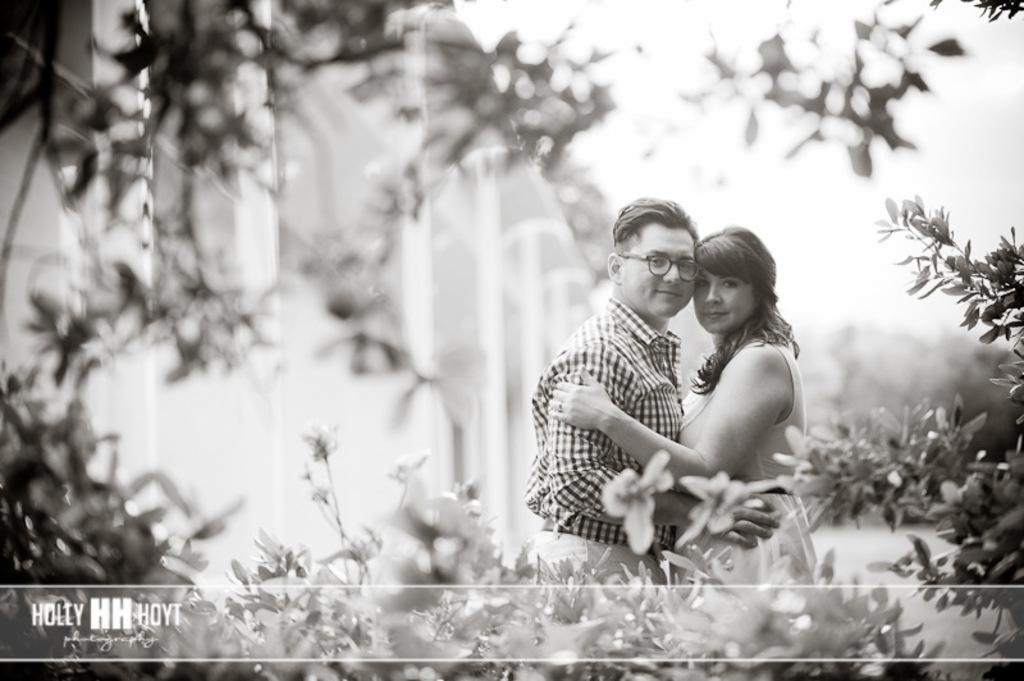What is the color scheme of the image? The image is black and white. How many people are present in the image? There are two people in the image. What type of objects can be seen in the image? There are plants in the image. Can you describe any additional features of the image? There is a watermark at the bottom of the image, and the background is blurry. Can you hear the toad crying in the image? There is no toad or any sound present in the image, as it is a still, black and white photograph. 